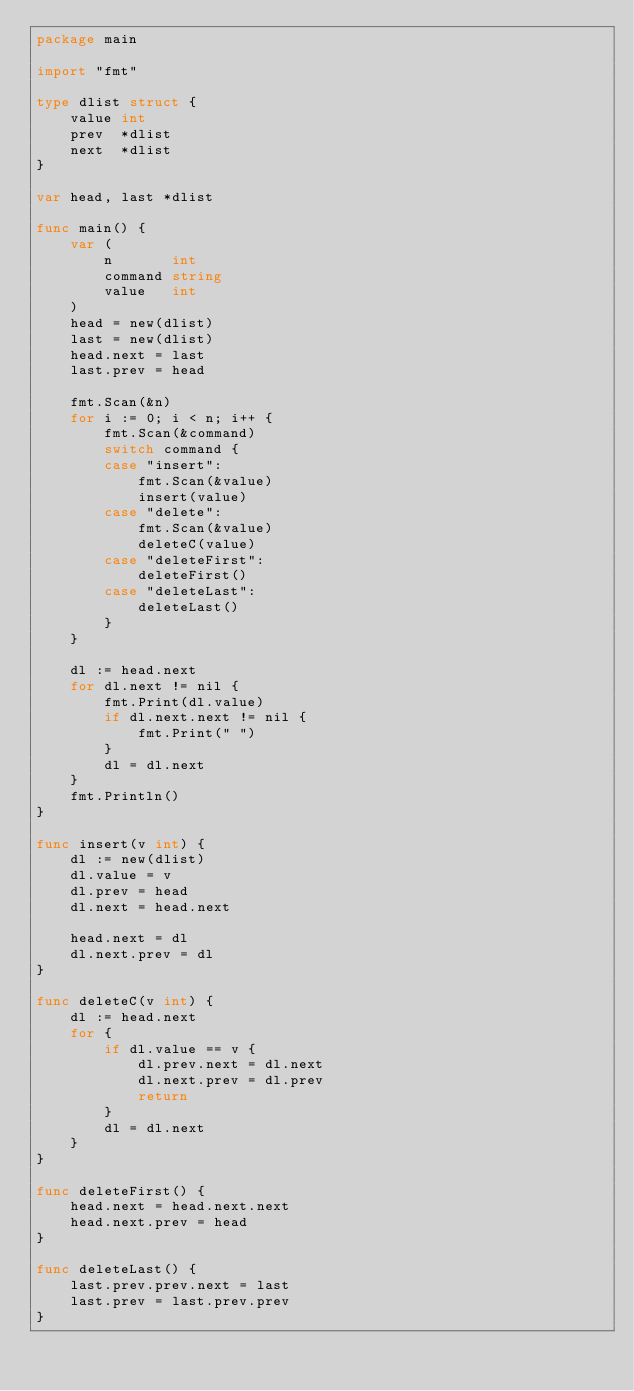<code> <loc_0><loc_0><loc_500><loc_500><_Go_>package main

import "fmt"

type dlist struct {
	value int
	prev  *dlist
	next  *dlist
}

var head, last *dlist

func main() {
	var (
		n       int
		command string
		value   int
	)
	head = new(dlist)
	last = new(dlist)
	head.next = last
	last.prev = head

	fmt.Scan(&n)
	for i := 0; i < n; i++ {
		fmt.Scan(&command)
		switch command {
		case "insert":
			fmt.Scan(&value)
			insert(value)
		case "delete":
			fmt.Scan(&value)
			deleteC(value)
		case "deleteFirst":
			deleteFirst()
		case "deleteLast":
			deleteLast()
		}
	}

	dl := head.next
	for dl.next != nil {
		fmt.Print(dl.value)
		if dl.next.next != nil {
			fmt.Print(" ")
		}
		dl = dl.next
	}
	fmt.Println()
}

func insert(v int) {
	dl := new(dlist)
	dl.value = v
	dl.prev = head
	dl.next = head.next

	head.next = dl
	dl.next.prev = dl
}

func deleteC(v int) {
	dl := head.next
	for {
		if dl.value == v {
			dl.prev.next = dl.next
			dl.next.prev = dl.prev
			return
		}
		dl = dl.next
	}
}

func deleteFirst() {
	head.next = head.next.next
	head.next.prev = head
}

func deleteLast() {
	last.prev.prev.next = last
	last.prev = last.prev.prev
}

</code> 